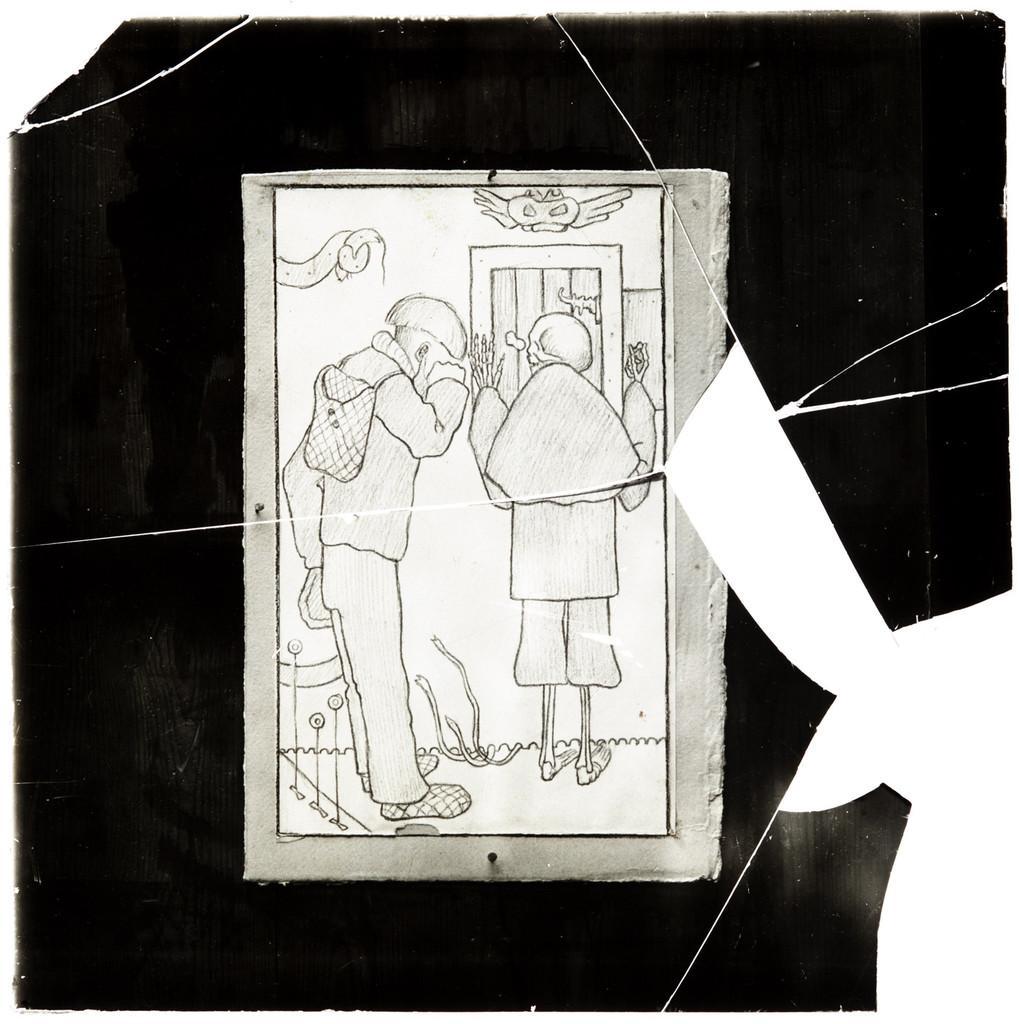How would you summarize this image in a sentence or two? In this image we can see a photo frame, in that we can see persons drawing, and the background is black and white in color. 